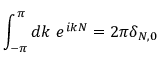<formula> <loc_0><loc_0><loc_500><loc_500>\int _ { - \pi } ^ { \pi } d k e ^ { i k N } = 2 \pi \delta _ { N , 0 }</formula> 